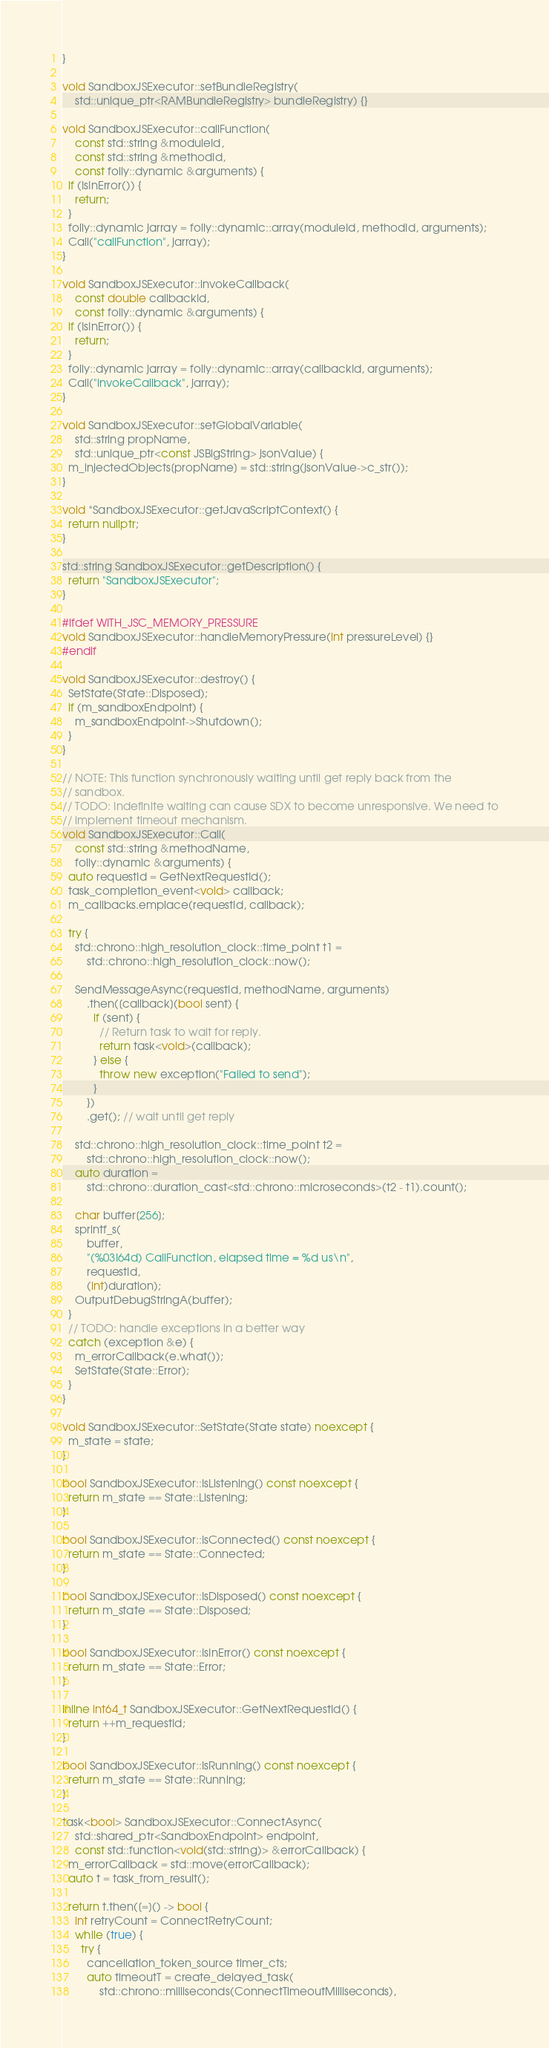<code> <loc_0><loc_0><loc_500><loc_500><_C++_>}

void SandboxJSExecutor::setBundleRegistry(
    std::unique_ptr<RAMBundleRegistry> bundleRegistry) {}

void SandboxJSExecutor::callFunction(
    const std::string &moduleId,
    const std::string &methodId,
    const folly::dynamic &arguments) {
  if (IsInError()) {
    return;
  }
  folly::dynamic jarray = folly::dynamic::array(moduleId, methodId, arguments);
  Call("callFunction", jarray);
}

void SandboxJSExecutor::invokeCallback(
    const double callbackId,
    const folly::dynamic &arguments) {
  if (IsInError()) {
    return;
  }
  folly::dynamic jarray = folly::dynamic::array(callbackId, arguments);
  Call("invokeCallback", jarray);
}

void SandboxJSExecutor::setGlobalVariable(
    std::string propName,
    std::unique_ptr<const JSBigString> jsonValue) {
  m_injectedObjects[propName] = std::string(jsonValue->c_str());
}

void *SandboxJSExecutor::getJavaScriptContext() {
  return nullptr;
}

std::string SandboxJSExecutor::getDescription() {
  return "SandboxJSExecutor";
}

#ifdef WITH_JSC_MEMORY_PRESSURE
void SandboxJSExecutor::handleMemoryPressure(int pressureLevel) {}
#endif

void SandboxJSExecutor::destroy() {
  SetState(State::Disposed);
  if (m_sandboxEndpoint) {
    m_sandboxEndpoint->Shutdown();
  }
}

// NOTE: This function synchronously waiting until get reply back from the
// sandbox.
// TODO: Indefinite waiting can cause SDX to become unresponsive. We need to
// implement timeout mechanism.
void SandboxJSExecutor::Call(
    const std::string &methodName,
    folly::dynamic &arguments) {
  auto requestId = GetNextRequestId();
  task_completion_event<void> callback;
  m_callbacks.emplace(requestId, callback);

  try {
    std::chrono::high_resolution_clock::time_point t1 =
        std::chrono::high_resolution_clock::now();

    SendMessageAsync(requestId, methodName, arguments)
        .then([callback](bool sent) {
          if (sent) {
            // Return task to wait for reply.
            return task<void>(callback);
          } else {
            throw new exception("Failed to send");
          }
        })
        .get(); // wait until get reply

    std::chrono::high_resolution_clock::time_point t2 =
        std::chrono::high_resolution_clock::now();
    auto duration =
        std::chrono::duration_cast<std::chrono::microseconds>(t2 - t1).count();

    char buffer[256];
    sprintf_s(
        buffer,
        "(%03I64d) CallFunction, elapsed time = %d us\n",
        requestId,
        (int)duration);
    OutputDebugStringA(buffer);
  }
  // TODO: handle exceptions in a better way
  catch (exception &e) {
    m_errorCallback(e.what());
    SetState(State::Error);
  }
}

void SandboxJSExecutor::SetState(State state) noexcept {
  m_state = state;
}

bool SandboxJSExecutor::IsListening() const noexcept {
  return m_state == State::Listening;
}

bool SandboxJSExecutor::IsConnected() const noexcept {
  return m_state == State::Connected;
}

bool SandboxJSExecutor::IsDisposed() const noexcept {
  return m_state == State::Disposed;
}

bool SandboxJSExecutor::IsInError() const noexcept {
  return m_state == State::Error;
}

inline int64_t SandboxJSExecutor::GetNextRequestId() {
  return ++m_requestId;
}

bool SandboxJSExecutor::IsRunning() const noexcept {
  return m_state == State::Running;
}

task<bool> SandboxJSExecutor::ConnectAsync(
    std::shared_ptr<SandboxEndpoint> endpoint,
    const std::function<void(std::string)> &errorCallback) {
  m_errorCallback = std::move(errorCallback);
  auto t = task_from_result();

  return t.then([=]() -> bool {
    int retryCount = ConnectRetryCount;
    while (true) {
      try {
        cancellation_token_source timer_cts;
        auto timeoutT = create_delayed_task(
            std::chrono::milliseconds(ConnectTimeoutMilliseconds),</code> 